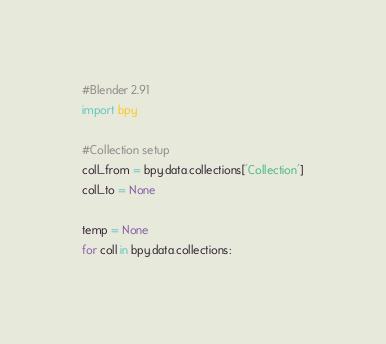<code> <loc_0><loc_0><loc_500><loc_500><_Python_>#Blender 2.91
import bpy

#Collection setup
coll_from = bpy.data.collections['Collection']
coll_to = None

temp = None
for coll in bpy.data.collections:</code> 